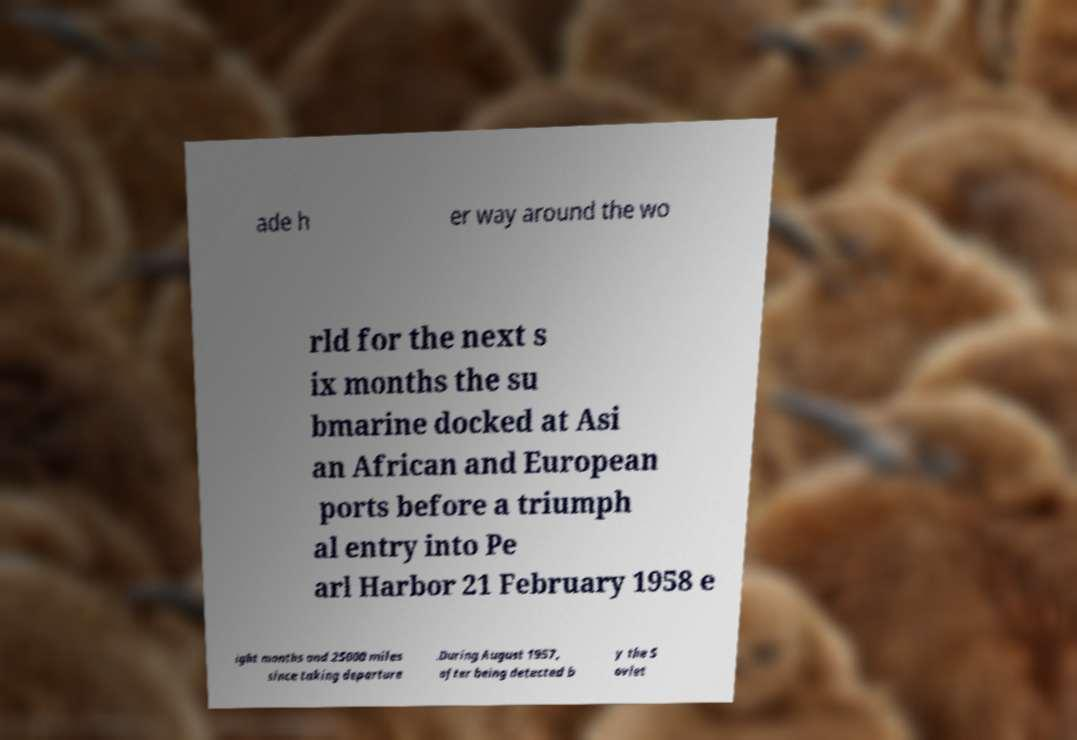Please identify and transcribe the text found in this image. ade h er way around the wo rld for the next s ix months the su bmarine docked at Asi an African and European ports before a triumph al entry into Pe arl Harbor 21 February 1958 e ight months and 25000 miles since taking departure .During August 1957, after being detected b y the S oviet 